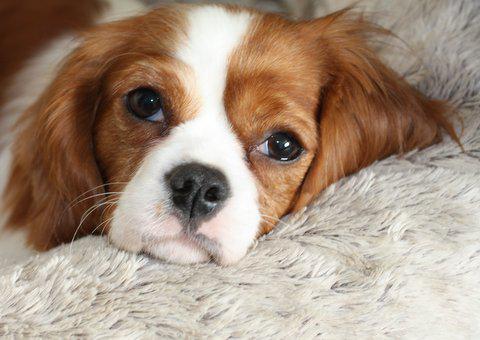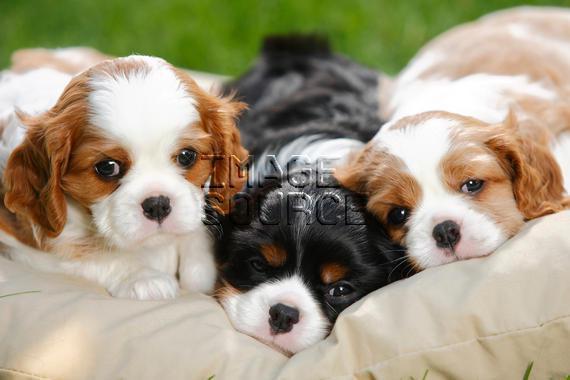The first image is the image on the left, the second image is the image on the right. Evaluate the accuracy of this statement regarding the images: "There are more dogs in the image on the left than in the image on the right.". Is it true? Answer yes or no. No. The first image is the image on the left, the second image is the image on the right. For the images shown, is this caption "One image shows a trio of reclining puppies, with the middle one flanked by two dogs with matching coloring." true? Answer yes or no. Yes. 